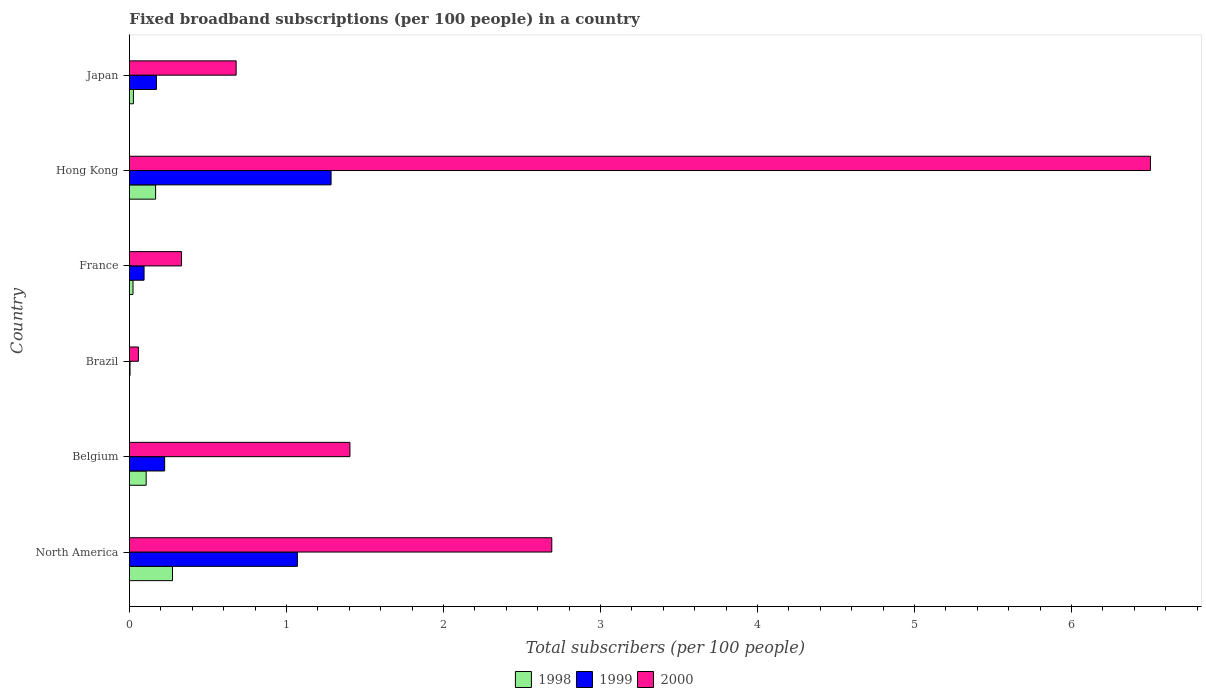How many different coloured bars are there?
Give a very brief answer. 3. Are the number of bars per tick equal to the number of legend labels?
Your answer should be very brief. Yes. What is the label of the 2nd group of bars from the top?
Provide a short and direct response. Hong Kong. What is the number of broadband subscriptions in 1999 in North America?
Make the answer very short. 1.07. Across all countries, what is the maximum number of broadband subscriptions in 2000?
Offer a terse response. 6.5. Across all countries, what is the minimum number of broadband subscriptions in 2000?
Your response must be concise. 0.06. In which country was the number of broadband subscriptions in 1998 maximum?
Ensure brevity in your answer.  North America. In which country was the number of broadband subscriptions in 2000 minimum?
Your answer should be compact. Brazil. What is the total number of broadband subscriptions in 1999 in the graph?
Offer a terse response. 2.85. What is the difference between the number of broadband subscriptions in 1999 in Belgium and that in North America?
Offer a terse response. -0.85. What is the difference between the number of broadband subscriptions in 2000 in North America and the number of broadband subscriptions in 1998 in France?
Your response must be concise. 2.67. What is the average number of broadband subscriptions in 1999 per country?
Your answer should be compact. 0.47. What is the difference between the number of broadband subscriptions in 2000 and number of broadband subscriptions in 1999 in Belgium?
Give a very brief answer. 1.18. In how many countries, is the number of broadband subscriptions in 1998 greater than 6.2 ?
Give a very brief answer. 0. What is the ratio of the number of broadband subscriptions in 1999 in France to that in Hong Kong?
Provide a short and direct response. 0.07. Is the number of broadband subscriptions in 1999 in France less than that in Japan?
Provide a short and direct response. Yes. Is the difference between the number of broadband subscriptions in 2000 in Brazil and France greater than the difference between the number of broadband subscriptions in 1999 in Brazil and France?
Your answer should be compact. No. What is the difference between the highest and the second highest number of broadband subscriptions in 1998?
Provide a succinct answer. 0.11. What is the difference between the highest and the lowest number of broadband subscriptions in 2000?
Your response must be concise. 6.44. In how many countries, is the number of broadband subscriptions in 1999 greater than the average number of broadband subscriptions in 1999 taken over all countries?
Make the answer very short. 2. Is the sum of the number of broadband subscriptions in 1999 in France and Japan greater than the maximum number of broadband subscriptions in 1998 across all countries?
Keep it short and to the point. No. How many bars are there?
Provide a succinct answer. 18. Are all the bars in the graph horizontal?
Provide a succinct answer. Yes. What is the difference between two consecutive major ticks on the X-axis?
Make the answer very short. 1. Does the graph contain any zero values?
Give a very brief answer. No. How are the legend labels stacked?
Your answer should be very brief. Horizontal. What is the title of the graph?
Provide a succinct answer. Fixed broadband subscriptions (per 100 people) in a country. What is the label or title of the X-axis?
Offer a terse response. Total subscribers (per 100 people). What is the label or title of the Y-axis?
Your answer should be compact. Country. What is the Total subscribers (per 100 people) of 1998 in North America?
Ensure brevity in your answer.  0.27. What is the Total subscribers (per 100 people) of 1999 in North America?
Make the answer very short. 1.07. What is the Total subscribers (per 100 people) of 2000 in North America?
Keep it short and to the point. 2.69. What is the Total subscribers (per 100 people) in 1998 in Belgium?
Offer a very short reply. 0.11. What is the Total subscribers (per 100 people) of 1999 in Belgium?
Provide a succinct answer. 0.22. What is the Total subscribers (per 100 people) of 2000 in Belgium?
Make the answer very short. 1.4. What is the Total subscribers (per 100 people) of 1998 in Brazil?
Your answer should be compact. 0. What is the Total subscribers (per 100 people) in 1999 in Brazil?
Provide a succinct answer. 0. What is the Total subscribers (per 100 people) in 2000 in Brazil?
Keep it short and to the point. 0.06. What is the Total subscribers (per 100 people) of 1998 in France?
Offer a very short reply. 0.02. What is the Total subscribers (per 100 people) in 1999 in France?
Provide a short and direct response. 0.09. What is the Total subscribers (per 100 people) in 2000 in France?
Keep it short and to the point. 0.33. What is the Total subscribers (per 100 people) in 1998 in Hong Kong?
Provide a short and direct response. 0.17. What is the Total subscribers (per 100 people) of 1999 in Hong Kong?
Make the answer very short. 1.28. What is the Total subscribers (per 100 people) of 2000 in Hong Kong?
Provide a succinct answer. 6.5. What is the Total subscribers (per 100 people) in 1998 in Japan?
Keep it short and to the point. 0.03. What is the Total subscribers (per 100 people) in 1999 in Japan?
Provide a short and direct response. 0.17. What is the Total subscribers (per 100 people) of 2000 in Japan?
Make the answer very short. 0.68. Across all countries, what is the maximum Total subscribers (per 100 people) of 1998?
Your answer should be compact. 0.27. Across all countries, what is the maximum Total subscribers (per 100 people) of 1999?
Provide a short and direct response. 1.28. Across all countries, what is the maximum Total subscribers (per 100 people) of 2000?
Your response must be concise. 6.5. Across all countries, what is the minimum Total subscribers (per 100 people) in 1998?
Offer a terse response. 0. Across all countries, what is the minimum Total subscribers (per 100 people) in 1999?
Make the answer very short. 0. Across all countries, what is the minimum Total subscribers (per 100 people) in 2000?
Provide a short and direct response. 0.06. What is the total Total subscribers (per 100 people) in 1998 in the graph?
Offer a very short reply. 0.6. What is the total Total subscribers (per 100 people) of 1999 in the graph?
Your response must be concise. 2.85. What is the total Total subscribers (per 100 people) of 2000 in the graph?
Give a very brief answer. 11.67. What is the difference between the Total subscribers (per 100 people) of 1998 in North America and that in Belgium?
Make the answer very short. 0.17. What is the difference between the Total subscribers (per 100 people) of 1999 in North America and that in Belgium?
Make the answer very short. 0.85. What is the difference between the Total subscribers (per 100 people) in 2000 in North America and that in Belgium?
Give a very brief answer. 1.29. What is the difference between the Total subscribers (per 100 people) in 1998 in North America and that in Brazil?
Provide a succinct answer. 0.27. What is the difference between the Total subscribers (per 100 people) in 1999 in North America and that in Brazil?
Keep it short and to the point. 1.07. What is the difference between the Total subscribers (per 100 people) of 2000 in North America and that in Brazil?
Give a very brief answer. 2.63. What is the difference between the Total subscribers (per 100 people) of 1998 in North America and that in France?
Ensure brevity in your answer.  0.25. What is the difference between the Total subscribers (per 100 people) in 1999 in North America and that in France?
Keep it short and to the point. 0.98. What is the difference between the Total subscribers (per 100 people) of 2000 in North America and that in France?
Ensure brevity in your answer.  2.36. What is the difference between the Total subscribers (per 100 people) of 1998 in North America and that in Hong Kong?
Provide a short and direct response. 0.11. What is the difference between the Total subscribers (per 100 people) in 1999 in North America and that in Hong Kong?
Your response must be concise. -0.21. What is the difference between the Total subscribers (per 100 people) in 2000 in North America and that in Hong Kong?
Give a very brief answer. -3.81. What is the difference between the Total subscribers (per 100 people) in 1998 in North America and that in Japan?
Your answer should be very brief. 0.25. What is the difference between the Total subscribers (per 100 people) in 1999 in North America and that in Japan?
Keep it short and to the point. 0.9. What is the difference between the Total subscribers (per 100 people) of 2000 in North America and that in Japan?
Make the answer very short. 2.01. What is the difference between the Total subscribers (per 100 people) of 1998 in Belgium and that in Brazil?
Ensure brevity in your answer.  0.11. What is the difference between the Total subscribers (per 100 people) of 1999 in Belgium and that in Brazil?
Provide a short and direct response. 0.22. What is the difference between the Total subscribers (per 100 people) of 2000 in Belgium and that in Brazil?
Keep it short and to the point. 1.35. What is the difference between the Total subscribers (per 100 people) in 1998 in Belgium and that in France?
Your answer should be very brief. 0.08. What is the difference between the Total subscribers (per 100 people) of 1999 in Belgium and that in France?
Ensure brevity in your answer.  0.13. What is the difference between the Total subscribers (per 100 people) in 2000 in Belgium and that in France?
Give a very brief answer. 1.07. What is the difference between the Total subscribers (per 100 people) of 1998 in Belgium and that in Hong Kong?
Your answer should be very brief. -0.06. What is the difference between the Total subscribers (per 100 people) in 1999 in Belgium and that in Hong Kong?
Your response must be concise. -1.06. What is the difference between the Total subscribers (per 100 people) of 2000 in Belgium and that in Hong Kong?
Provide a short and direct response. -5.1. What is the difference between the Total subscribers (per 100 people) in 1998 in Belgium and that in Japan?
Offer a terse response. 0.08. What is the difference between the Total subscribers (per 100 people) in 1999 in Belgium and that in Japan?
Your answer should be compact. 0.05. What is the difference between the Total subscribers (per 100 people) of 2000 in Belgium and that in Japan?
Keep it short and to the point. 0.72. What is the difference between the Total subscribers (per 100 people) of 1998 in Brazil and that in France?
Provide a short and direct response. -0.02. What is the difference between the Total subscribers (per 100 people) of 1999 in Brazil and that in France?
Your answer should be compact. -0.09. What is the difference between the Total subscribers (per 100 people) of 2000 in Brazil and that in France?
Your answer should be very brief. -0.27. What is the difference between the Total subscribers (per 100 people) in 1998 in Brazil and that in Hong Kong?
Your answer should be compact. -0.17. What is the difference between the Total subscribers (per 100 people) of 1999 in Brazil and that in Hong Kong?
Your answer should be compact. -1.28. What is the difference between the Total subscribers (per 100 people) of 2000 in Brazil and that in Hong Kong?
Make the answer very short. -6.45. What is the difference between the Total subscribers (per 100 people) in 1998 in Brazil and that in Japan?
Provide a succinct answer. -0.03. What is the difference between the Total subscribers (per 100 people) in 1999 in Brazil and that in Japan?
Make the answer very short. -0.17. What is the difference between the Total subscribers (per 100 people) in 2000 in Brazil and that in Japan?
Your answer should be very brief. -0.62. What is the difference between the Total subscribers (per 100 people) of 1998 in France and that in Hong Kong?
Your answer should be compact. -0.14. What is the difference between the Total subscribers (per 100 people) in 1999 in France and that in Hong Kong?
Ensure brevity in your answer.  -1.19. What is the difference between the Total subscribers (per 100 people) of 2000 in France and that in Hong Kong?
Provide a succinct answer. -6.17. What is the difference between the Total subscribers (per 100 people) of 1998 in France and that in Japan?
Ensure brevity in your answer.  -0. What is the difference between the Total subscribers (per 100 people) in 1999 in France and that in Japan?
Your answer should be compact. -0.08. What is the difference between the Total subscribers (per 100 people) in 2000 in France and that in Japan?
Keep it short and to the point. -0.35. What is the difference between the Total subscribers (per 100 people) in 1998 in Hong Kong and that in Japan?
Your answer should be very brief. 0.14. What is the difference between the Total subscribers (per 100 people) in 1999 in Hong Kong and that in Japan?
Make the answer very short. 1.11. What is the difference between the Total subscribers (per 100 people) of 2000 in Hong Kong and that in Japan?
Give a very brief answer. 5.82. What is the difference between the Total subscribers (per 100 people) in 1998 in North America and the Total subscribers (per 100 people) in 1999 in Belgium?
Provide a succinct answer. 0.05. What is the difference between the Total subscribers (per 100 people) of 1998 in North America and the Total subscribers (per 100 people) of 2000 in Belgium?
Your response must be concise. -1.13. What is the difference between the Total subscribers (per 100 people) in 1999 in North America and the Total subscribers (per 100 people) in 2000 in Belgium?
Keep it short and to the point. -0.33. What is the difference between the Total subscribers (per 100 people) of 1998 in North America and the Total subscribers (per 100 people) of 1999 in Brazil?
Ensure brevity in your answer.  0.27. What is the difference between the Total subscribers (per 100 people) in 1998 in North America and the Total subscribers (per 100 people) in 2000 in Brazil?
Make the answer very short. 0.22. What is the difference between the Total subscribers (per 100 people) of 1999 in North America and the Total subscribers (per 100 people) of 2000 in Brazil?
Provide a short and direct response. 1.01. What is the difference between the Total subscribers (per 100 people) in 1998 in North America and the Total subscribers (per 100 people) in 1999 in France?
Your response must be concise. 0.18. What is the difference between the Total subscribers (per 100 people) in 1998 in North America and the Total subscribers (per 100 people) in 2000 in France?
Ensure brevity in your answer.  -0.06. What is the difference between the Total subscribers (per 100 people) of 1999 in North America and the Total subscribers (per 100 people) of 2000 in France?
Your answer should be very brief. 0.74. What is the difference between the Total subscribers (per 100 people) of 1998 in North America and the Total subscribers (per 100 people) of 1999 in Hong Kong?
Offer a very short reply. -1.01. What is the difference between the Total subscribers (per 100 people) in 1998 in North America and the Total subscribers (per 100 people) in 2000 in Hong Kong?
Your answer should be compact. -6.23. What is the difference between the Total subscribers (per 100 people) of 1999 in North America and the Total subscribers (per 100 people) of 2000 in Hong Kong?
Make the answer very short. -5.43. What is the difference between the Total subscribers (per 100 people) of 1998 in North America and the Total subscribers (per 100 people) of 1999 in Japan?
Provide a succinct answer. 0.1. What is the difference between the Total subscribers (per 100 people) of 1998 in North America and the Total subscribers (per 100 people) of 2000 in Japan?
Your response must be concise. -0.41. What is the difference between the Total subscribers (per 100 people) of 1999 in North America and the Total subscribers (per 100 people) of 2000 in Japan?
Your answer should be very brief. 0.39. What is the difference between the Total subscribers (per 100 people) in 1998 in Belgium and the Total subscribers (per 100 people) in 1999 in Brazil?
Your response must be concise. 0.1. What is the difference between the Total subscribers (per 100 people) of 1998 in Belgium and the Total subscribers (per 100 people) of 2000 in Brazil?
Your response must be concise. 0.05. What is the difference between the Total subscribers (per 100 people) of 1999 in Belgium and the Total subscribers (per 100 people) of 2000 in Brazil?
Your answer should be compact. 0.17. What is the difference between the Total subscribers (per 100 people) of 1998 in Belgium and the Total subscribers (per 100 people) of 1999 in France?
Keep it short and to the point. 0.01. What is the difference between the Total subscribers (per 100 people) of 1998 in Belgium and the Total subscribers (per 100 people) of 2000 in France?
Offer a very short reply. -0.23. What is the difference between the Total subscribers (per 100 people) of 1999 in Belgium and the Total subscribers (per 100 people) of 2000 in France?
Offer a terse response. -0.11. What is the difference between the Total subscribers (per 100 people) in 1998 in Belgium and the Total subscribers (per 100 people) in 1999 in Hong Kong?
Your answer should be very brief. -1.18. What is the difference between the Total subscribers (per 100 people) in 1998 in Belgium and the Total subscribers (per 100 people) in 2000 in Hong Kong?
Your answer should be compact. -6.4. What is the difference between the Total subscribers (per 100 people) of 1999 in Belgium and the Total subscribers (per 100 people) of 2000 in Hong Kong?
Offer a terse response. -6.28. What is the difference between the Total subscribers (per 100 people) of 1998 in Belgium and the Total subscribers (per 100 people) of 1999 in Japan?
Ensure brevity in your answer.  -0.07. What is the difference between the Total subscribers (per 100 people) of 1998 in Belgium and the Total subscribers (per 100 people) of 2000 in Japan?
Your response must be concise. -0.57. What is the difference between the Total subscribers (per 100 people) of 1999 in Belgium and the Total subscribers (per 100 people) of 2000 in Japan?
Your answer should be very brief. -0.46. What is the difference between the Total subscribers (per 100 people) of 1998 in Brazil and the Total subscribers (per 100 people) of 1999 in France?
Ensure brevity in your answer.  -0.09. What is the difference between the Total subscribers (per 100 people) in 1998 in Brazil and the Total subscribers (per 100 people) in 2000 in France?
Your answer should be very brief. -0.33. What is the difference between the Total subscribers (per 100 people) of 1999 in Brazil and the Total subscribers (per 100 people) of 2000 in France?
Offer a very short reply. -0.33. What is the difference between the Total subscribers (per 100 people) in 1998 in Brazil and the Total subscribers (per 100 people) in 1999 in Hong Kong?
Keep it short and to the point. -1.28. What is the difference between the Total subscribers (per 100 people) of 1998 in Brazil and the Total subscribers (per 100 people) of 2000 in Hong Kong?
Your answer should be very brief. -6.5. What is the difference between the Total subscribers (per 100 people) in 1999 in Brazil and the Total subscribers (per 100 people) in 2000 in Hong Kong?
Provide a short and direct response. -6.5. What is the difference between the Total subscribers (per 100 people) of 1998 in Brazil and the Total subscribers (per 100 people) of 1999 in Japan?
Give a very brief answer. -0.17. What is the difference between the Total subscribers (per 100 people) in 1998 in Brazil and the Total subscribers (per 100 people) in 2000 in Japan?
Make the answer very short. -0.68. What is the difference between the Total subscribers (per 100 people) in 1999 in Brazil and the Total subscribers (per 100 people) in 2000 in Japan?
Ensure brevity in your answer.  -0.68. What is the difference between the Total subscribers (per 100 people) in 1998 in France and the Total subscribers (per 100 people) in 1999 in Hong Kong?
Offer a very short reply. -1.26. What is the difference between the Total subscribers (per 100 people) of 1998 in France and the Total subscribers (per 100 people) of 2000 in Hong Kong?
Keep it short and to the point. -6.48. What is the difference between the Total subscribers (per 100 people) of 1999 in France and the Total subscribers (per 100 people) of 2000 in Hong Kong?
Your answer should be compact. -6.41. What is the difference between the Total subscribers (per 100 people) of 1998 in France and the Total subscribers (per 100 people) of 1999 in Japan?
Give a very brief answer. -0.15. What is the difference between the Total subscribers (per 100 people) in 1998 in France and the Total subscribers (per 100 people) in 2000 in Japan?
Offer a very short reply. -0.66. What is the difference between the Total subscribers (per 100 people) in 1999 in France and the Total subscribers (per 100 people) in 2000 in Japan?
Offer a very short reply. -0.59. What is the difference between the Total subscribers (per 100 people) of 1998 in Hong Kong and the Total subscribers (per 100 people) of 1999 in Japan?
Your response must be concise. -0.01. What is the difference between the Total subscribers (per 100 people) of 1998 in Hong Kong and the Total subscribers (per 100 people) of 2000 in Japan?
Your response must be concise. -0.51. What is the difference between the Total subscribers (per 100 people) of 1999 in Hong Kong and the Total subscribers (per 100 people) of 2000 in Japan?
Keep it short and to the point. 0.6. What is the average Total subscribers (per 100 people) of 1998 per country?
Provide a short and direct response. 0.1. What is the average Total subscribers (per 100 people) of 1999 per country?
Your answer should be compact. 0.47. What is the average Total subscribers (per 100 people) in 2000 per country?
Make the answer very short. 1.94. What is the difference between the Total subscribers (per 100 people) of 1998 and Total subscribers (per 100 people) of 1999 in North America?
Make the answer very short. -0.8. What is the difference between the Total subscribers (per 100 people) of 1998 and Total subscribers (per 100 people) of 2000 in North America?
Give a very brief answer. -2.42. What is the difference between the Total subscribers (per 100 people) of 1999 and Total subscribers (per 100 people) of 2000 in North America?
Provide a succinct answer. -1.62. What is the difference between the Total subscribers (per 100 people) of 1998 and Total subscribers (per 100 people) of 1999 in Belgium?
Offer a terse response. -0.12. What is the difference between the Total subscribers (per 100 people) in 1998 and Total subscribers (per 100 people) in 2000 in Belgium?
Give a very brief answer. -1.3. What is the difference between the Total subscribers (per 100 people) of 1999 and Total subscribers (per 100 people) of 2000 in Belgium?
Keep it short and to the point. -1.18. What is the difference between the Total subscribers (per 100 people) in 1998 and Total subscribers (per 100 people) in 1999 in Brazil?
Make the answer very short. -0. What is the difference between the Total subscribers (per 100 people) of 1998 and Total subscribers (per 100 people) of 2000 in Brazil?
Provide a succinct answer. -0.06. What is the difference between the Total subscribers (per 100 people) of 1999 and Total subscribers (per 100 people) of 2000 in Brazil?
Ensure brevity in your answer.  -0.05. What is the difference between the Total subscribers (per 100 people) in 1998 and Total subscribers (per 100 people) in 1999 in France?
Your answer should be very brief. -0.07. What is the difference between the Total subscribers (per 100 people) of 1998 and Total subscribers (per 100 people) of 2000 in France?
Your answer should be compact. -0.31. What is the difference between the Total subscribers (per 100 people) of 1999 and Total subscribers (per 100 people) of 2000 in France?
Your response must be concise. -0.24. What is the difference between the Total subscribers (per 100 people) of 1998 and Total subscribers (per 100 people) of 1999 in Hong Kong?
Offer a very short reply. -1.12. What is the difference between the Total subscribers (per 100 people) in 1998 and Total subscribers (per 100 people) in 2000 in Hong Kong?
Your answer should be compact. -6.34. What is the difference between the Total subscribers (per 100 people) in 1999 and Total subscribers (per 100 people) in 2000 in Hong Kong?
Offer a very short reply. -5.22. What is the difference between the Total subscribers (per 100 people) in 1998 and Total subscribers (per 100 people) in 1999 in Japan?
Your answer should be very brief. -0.15. What is the difference between the Total subscribers (per 100 people) of 1998 and Total subscribers (per 100 people) of 2000 in Japan?
Provide a short and direct response. -0.65. What is the difference between the Total subscribers (per 100 people) in 1999 and Total subscribers (per 100 people) in 2000 in Japan?
Offer a terse response. -0.51. What is the ratio of the Total subscribers (per 100 people) in 1998 in North America to that in Belgium?
Make the answer very short. 2.57. What is the ratio of the Total subscribers (per 100 people) of 1999 in North America to that in Belgium?
Make the answer very short. 4.76. What is the ratio of the Total subscribers (per 100 people) of 2000 in North America to that in Belgium?
Offer a terse response. 1.92. What is the ratio of the Total subscribers (per 100 people) in 1998 in North America to that in Brazil?
Your answer should be compact. 465.15. What is the ratio of the Total subscribers (per 100 people) of 1999 in North America to that in Brazil?
Keep it short and to the point. 262.9. What is the ratio of the Total subscribers (per 100 people) in 2000 in North America to that in Brazil?
Your answer should be very brief. 46.94. What is the ratio of the Total subscribers (per 100 people) in 1998 in North America to that in France?
Make the answer very short. 11.95. What is the ratio of the Total subscribers (per 100 people) in 1999 in North America to that in France?
Your response must be concise. 11.46. What is the ratio of the Total subscribers (per 100 people) in 2000 in North America to that in France?
Offer a terse response. 8.1. What is the ratio of the Total subscribers (per 100 people) in 1998 in North America to that in Hong Kong?
Provide a succinct answer. 1.64. What is the ratio of the Total subscribers (per 100 people) of 1999 in North America to that in Hong Kong?
Provide a short and direct response. 0.83. What is the ratio of the Total subscribers (per 100 people) of 2000 in North America to that in Hong Kong?
Provide a short and direct response. 0.41. What is the ratio of the Total subscribers (per 100 people) of 1998 in North America to that in Japan?
Give a very brief answer. 10.74. What is the ratio of the Total subscribers (per 100 people) in 1999 in North America to that in Japan?
Offer a terse response. 6.22. What is the ratio of the Total subscribers (per 100 people) of 2000 in North America to that in Japan?
Offer a terse response. 3.96. What is the ratio of the Total subscribers (per 100 people) of 1998 in Belgium to that in Brazil?
Give a very brief answer. 181.1. What is the ratio of the Total subscribers (per 100 people) of 1999 in Belgium to that in Brazil?
Offer a very short reply. 55.18. What is the ratio of the Total subscribers (per 100 people) of 2000 in Belgium to that in Brazil?
Your answer should be compact. 24.51. What is the ratio of the Total subscribers (per 100 people) in 1998 in Belgium to that in France?
Give a very brief answer. 4.65. What is the ratio of the Total subscribers (per 100 people) of 1999 in Belgium to that in France?
Ensure brevity in your answer.  2.4. What is the ratio of the Total subscribers (per 100 people) in 2000 in Belgium to that in France?
Provide a short and direct response. 4.23. What is the ratio of the Total subscribers (per 100 people) in 1998 in Belgium to that in Hong Kong?
Offer a very short reply. 0.64. What is the ratio of the Total subscribers (per 100 people) of 1999 in Belgium to that in Hong Kong?
Make the answer very short. 0.17. What is the ratio of the Total subscribers (per 100 people) in 2000 in Belgium to that in Hong Kong?
Keep it short and to the point. 0.22. What is the ratio of the Total subscribers (per 100 people) in 1998 in Belgium to that in Japan?
Provide a short and direct response. 4.18. What is the ratio of the Total subscribers (per 100 people) of 1999 in Belgium to that in Japan?
Give a very brief answer. 1.3. What is the ratio of the Total subscribers (per 100 people) in 2000 in Belgium to that in Japan?
Offer a terse response. 2.07. What is the ratio of the Total subscribers (per 100 people) of 1998 in Brazil to that in France?
Offer a very short reply. 0.03. What is the ratio of the Total subscribers (per 100 people) in 1999 in Brazil to that in France?
Offer a terse response. 0.04. What is the ratio of the Total subscribers (per 100 people) of 2000 in Brazil to that in France?
Make the answer very short. 0.17. What is the ratio of the Total subscribers (per 100 people) of 1998 in Brazil to that in Hong Kong?
Your response must be concise. 0. What is the ratio of the Total subscribers (per 100 people) of 1999 in Brazil to that in Hong Kong?
Your response must be concise. 0. What is the ratio of the Total subscribers (per 100 people) of 2000 in Brazil to that in Hong Kong?
Keep it short and to the point. 0.01. What is the ratio of the Total subscribers (per 100 people) in 1998 in Brazil to that in Japan?
Your answer should be compact. 0.02. What is the ratio of the Total subscribers (per 100 people) of 1999 in Brazil to that in Japan?
Offer a very short reply. 0.02. What is the ratio of the Total subscribers (per 100 people) of 2000 in Brazil to that in Japan?
Your answer should be compact. 0.08. What is the ratio of the Total subscribers (per 100 people) in 1998 in France to that in Hong Kong?
Your response must be concise. 0.14. What is the ratio of the Total subscribers (per 100 people) of 1999 in France to that in Hong Kong?
Give a very brief answer. 0.07. What is the ratio of the Total subscribers (per 100 people) of 2000 in France to that in Hong Kong?
Ensure brevity in your answer.  0.05. What is the ratio of the Total subscribers (per 100 people) in 1998 in France to that in Japan?
Give a very brief answer. 0.9. What is the ratio of the Total subscribers (per 100 people) in 1999 in France to that in Japan?
Your answer should be very brief. 0.54. What is the ratio of the Total subscribers (per 100 people) of 2000 in France to that in Japan?
Ensure brevity in your answer.  0.49. What is the ratio of the Total subscribers (per 100 people) of 1998 in Hong Kong to that in Japan?
Provide a short and direct response. 6.53. What is the ratio of the Total subscribers (per 100 people) of 1999 in Hong Kong to that in Japan?
Your response must be concise. 7.46. What is the ratio of the Total subscribers (per 100 people) of 2000 in Hong Kong to that in Japan?
Give a very brief answer. 9.56. What is the difference between the highest and the second highest Total subscribers (per 100 people) in 1998?
Your response must be concise. 0.11. What is the difference between the highest and the second highest Total subscribers (per 100 people) of 1999?
Make the answer very short. 0.21. What is the difference between the highest and the second highest Total subscribers (per 100 people) in 2000?
Offer a terse response. 3.81. What is the difference between the highest and the lowest Total subscribers (per 100 people) of 1998?
Your response must be concise. 0.27. What is the difference between the highest and the lowest Total subscribers (per 100 people) in 1999?
Keep it short and to the point. 1.28. What is the difference between the highest and the lowest Total subscribers (per 100 people) of 2000?
Provide a short and direct response. 6.45. 